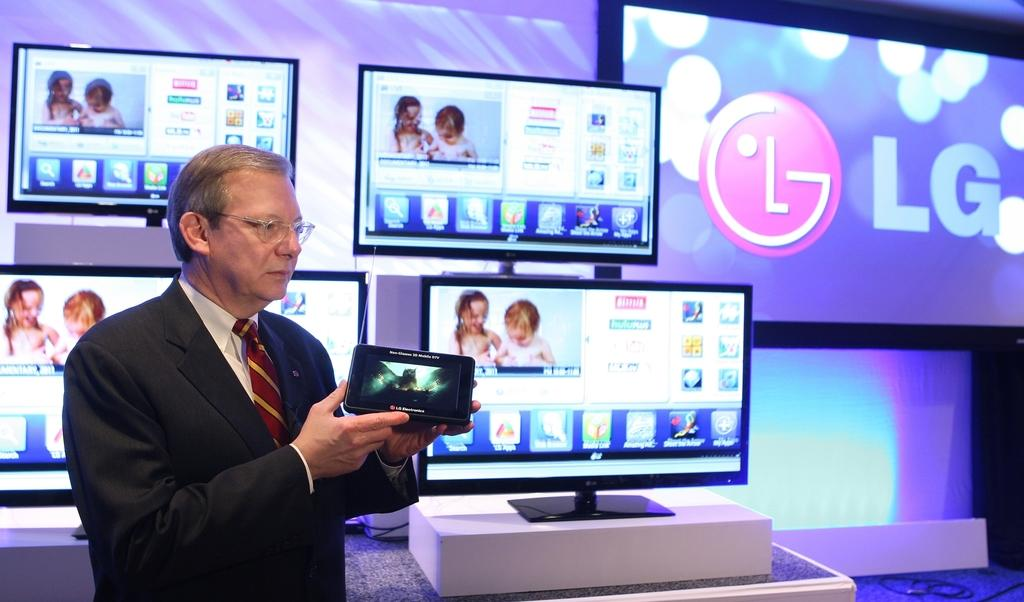<image>
Give a short and clear explanation of the subsequent image. A man is holding up a small tablet made by LG. 